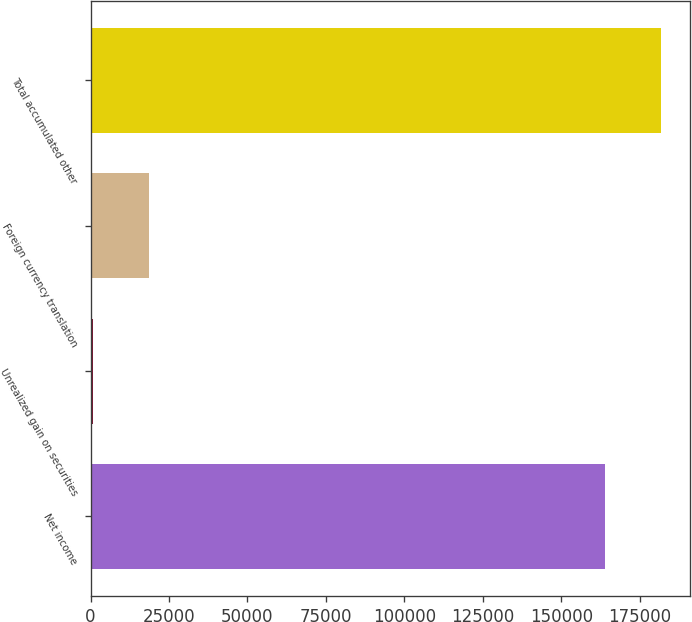Convert chart. <chart><loc_0><loc_0><loc_500><loc_500><bar_chart><fcel>Net income<fcel>Unrealized gain on securities<fcel>Foreign currency translation<fcel>Total accumulated other<nl><fcel>164061<fcel>846<fcel>18646.7<fcel>181862<nl></chart> 